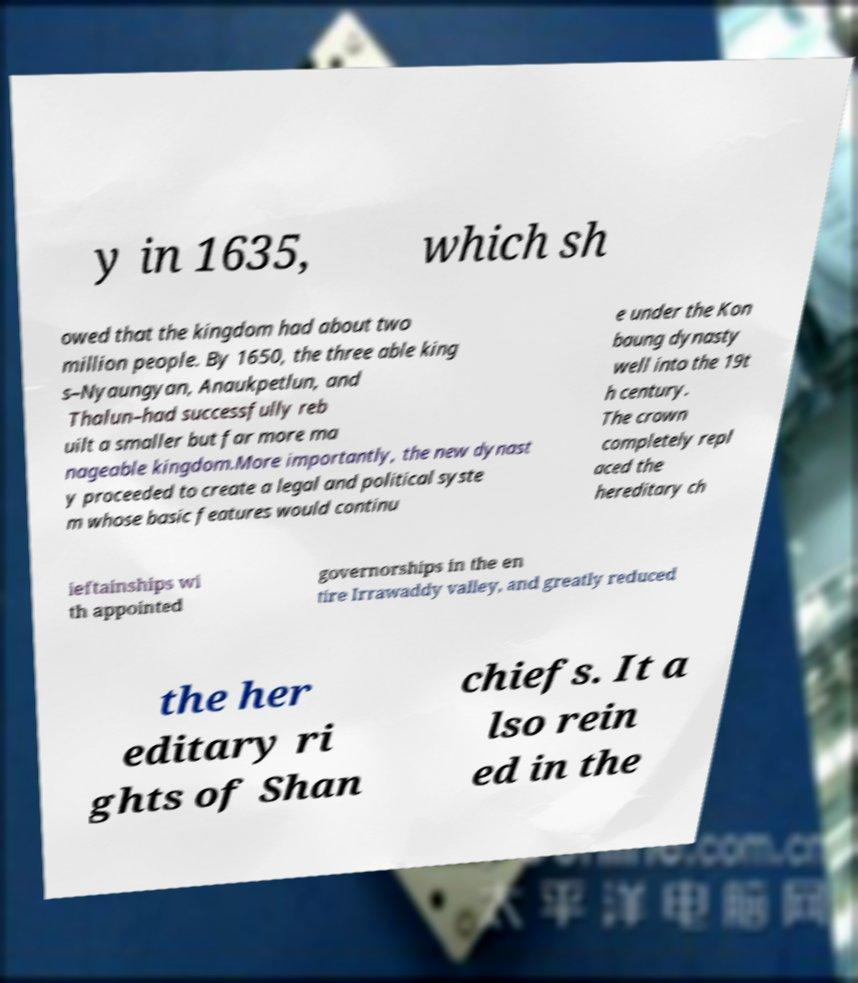Can you accurately transcribe the text from the provided image for me? y in 1635, which sh owed that the kingdom had about two million people. By 1650, the three able king s–Nyaungyan, Anaukpetlun, and Thalun–had successfully reb uilt a smaller but far more ma nageable kingdom.More importantly, the new dynast y proceeded to create a legal and political syste m whose basic features would continu e under the Kon baung dynasty well into the 19t h century. The crown completely repl aced the hereditary ch ieftainships wi th appointed governorships in the en tire Irrawaddy valley, and greatly reduced the her editary ri ghts of Shan chiefs. It a lso rein ed in the 